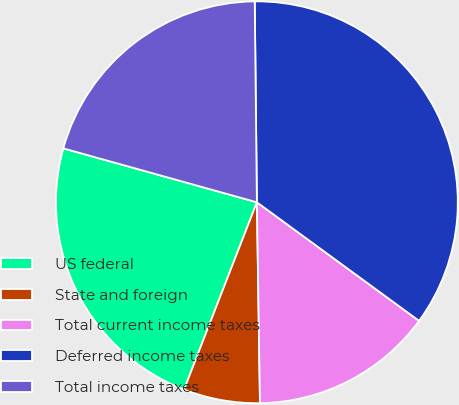<chart> <loc_0><loc_0><loc_500><loc_500><pie_chart><fcel>US federal<fcel>State and foreign<fcel>Total current income taxes<fcel>Deferred income taxes<fcel>Total income taxes<nl><fcel>23.42%<fcel>6.15%<fcel>14.71%<fcel>35.22%<fcel>20.51%<nl></chart> 